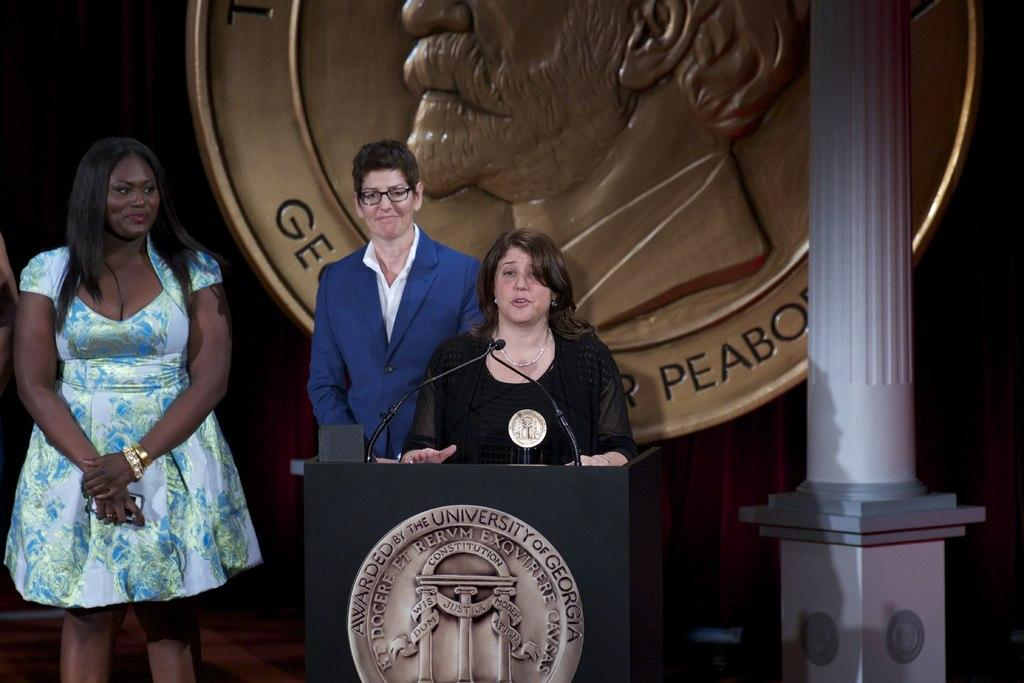How many people are in the image? There are three people in the image. What is in front of the people? There is a podium in front of the people. What can be seen near the podium? There are microphones near the podium. What is visible in the background of the image? There is a curtain, a shield, and a pole in the background of the image. What type of glove is being used by the people in the image? There is no glove visible in the image; the people are not wearing gloves. How are the people behaving in the image? The image does not show the behavior of the people; it only shows their position and the objects around them. 